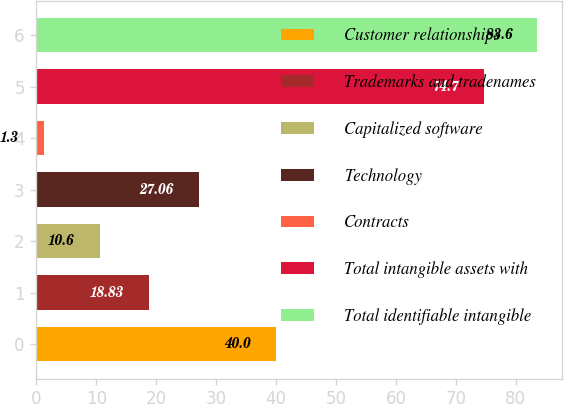Convert chart. <chart><loc_0><loc_0><loc_500><loc_500><bar_chart><fcel>Customer relationships<fcel>Trademarks and tradenames<fcel>Capitalized software<fcel>Technology<fcel>Contracts<fcel>Total intangible assets with<fcel>Total identifiable intangible<nl><fcel>40<fcel>18.83<fcel>10.6<fcel>27.06<fcel>1.3<fcel>74.7<fcel>83.6<nl></chart> 